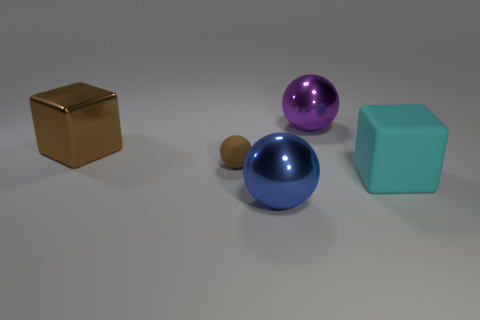What can you infer about the size of the objects relative to each other? The objects in the image are arranged in a way that suggests they vary in size. The cyan cube and the purple sphere are relatively large when compared to the smaller brown sphere and the even smaller marble. Size perception might be influenced by their proximity and the camera's perspective, but the objects clearly exhibit a hierarchy in scale ranging from large to small. 